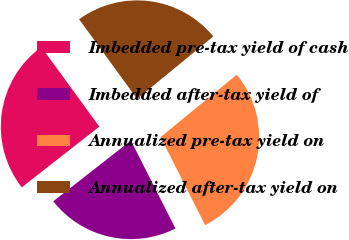<chart> <loc_0><loc_0><loc_500><loc_500><pie_chart><fcel>Imbedded pre-tax yield of cash<fcel>Imbedded after-tax yield of<fcel>Annualized pre-tax yield on<fcel>Annualized after-tax yield on<nl><fcel>25.55%<fcel>21.9%<fcel>28.47%<fcel>24.09%<nl></chart> 